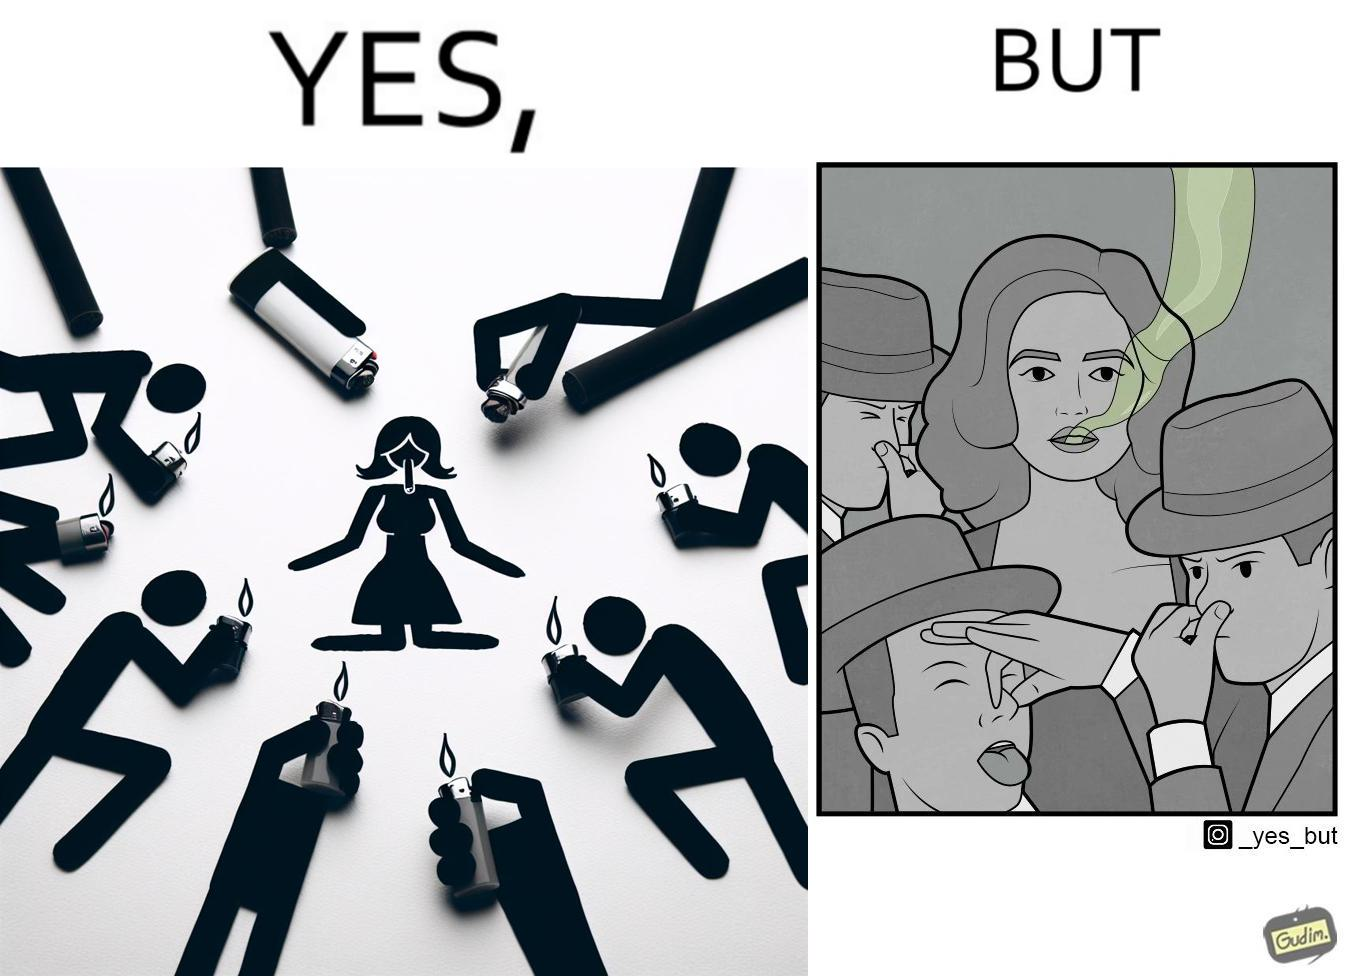What is shown in the left half versus the right half of this image? In the left part of the image: people holding lighters in front of a woman holding an unburnt cigarette in her mouth. In the right part of the image: people holding their noses on account of what appears to be bad smell coming out of a woman's mouth. 